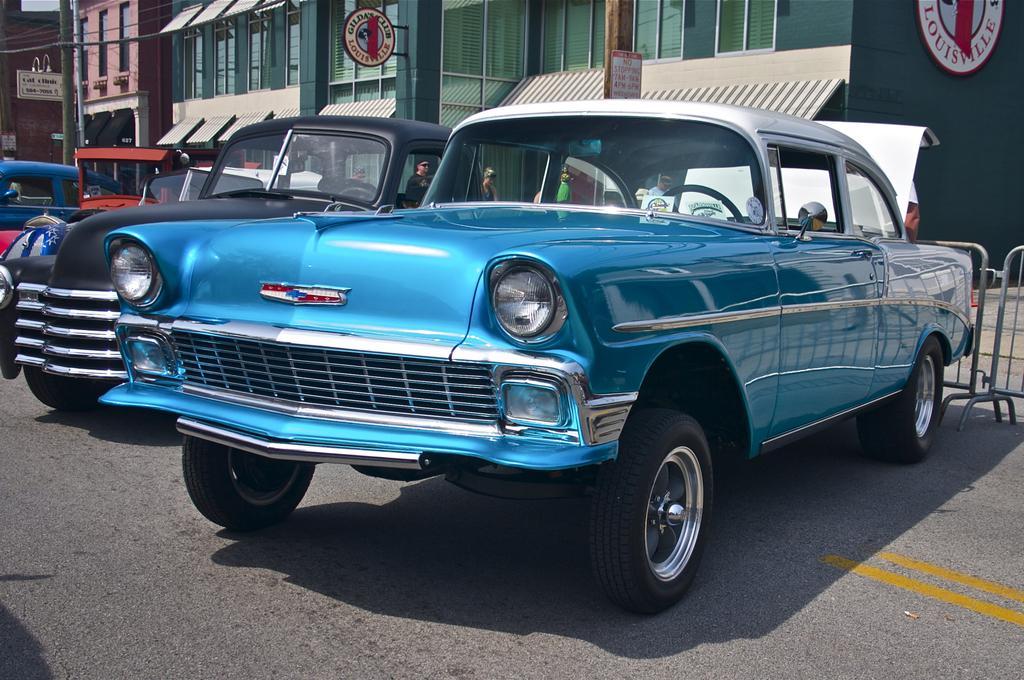In one or two sentences, can you explain what this image depicts? In this picture we can see few vehicles on the road, behind to the vehicles we can find fence, in the background we can see few buildings, hoardings, poles and group of people. 